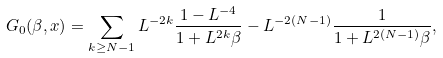Convert formula to latex. <formula><loc_0><loc_0><loc_500><loc_500>G _ { 0 } ( \beta , x ) = \sum _ { k \geq N - 1 } L ^ { - 2 k } \frac { 1 - L ^ { - 4 } } { 1 + L ^ { 2 k } \beta } - L ^ { - 2 ( N - 1 ) } \frac { 1 } { 1 + L ^ { 2 ( N - 1 ) } \beta } ,</formula> 